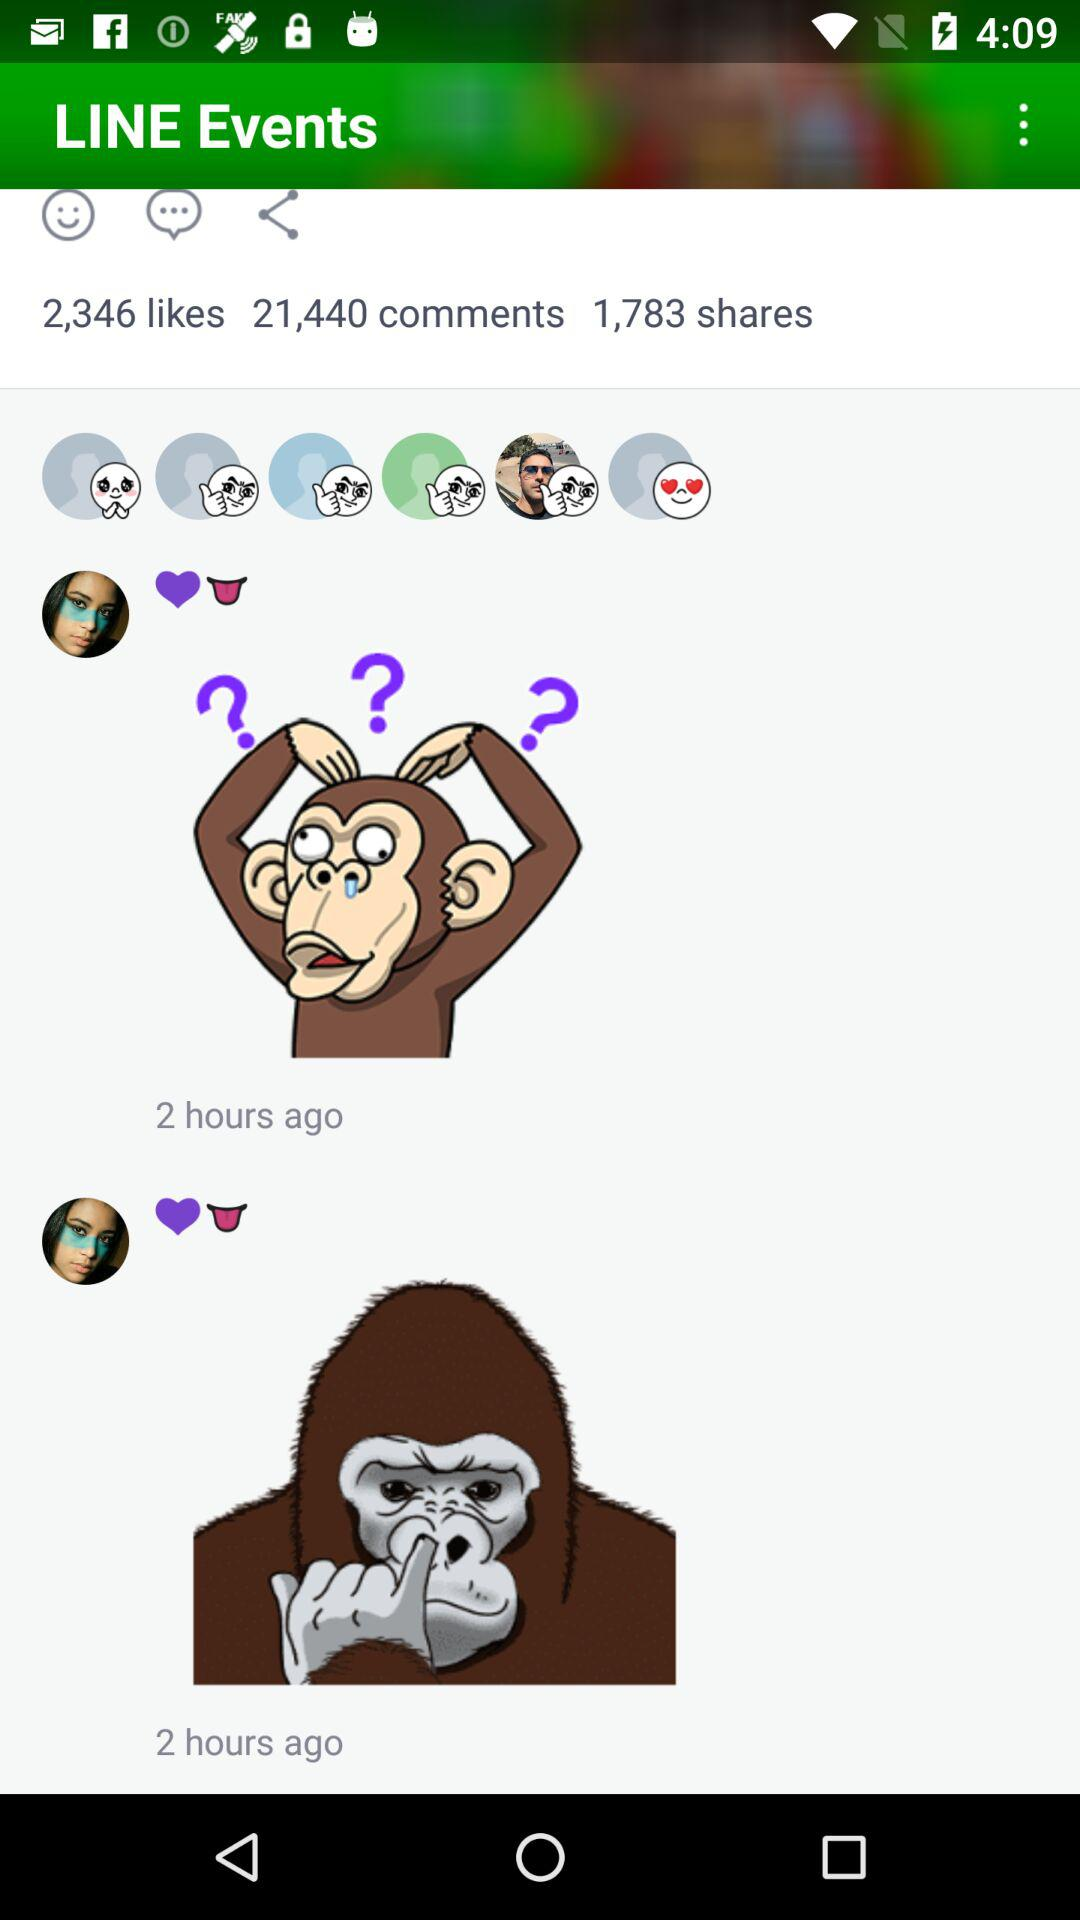How many likes are there? There are 2,346 likes. 